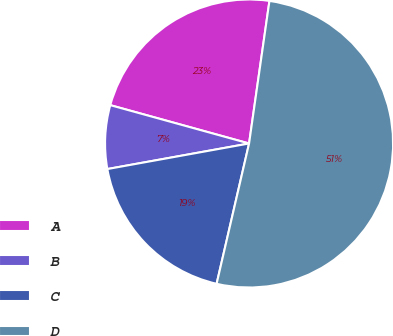Convert chart. <chart><loc_0><loc_0><loc_500><loc_500><pie_chart><fcel>A<fcel>B<fcel>C<fcel>D<nl><fcel>22.97%<fcel>7.13%<fcel>18.54%<fcel>51.36%<nl></chart> 